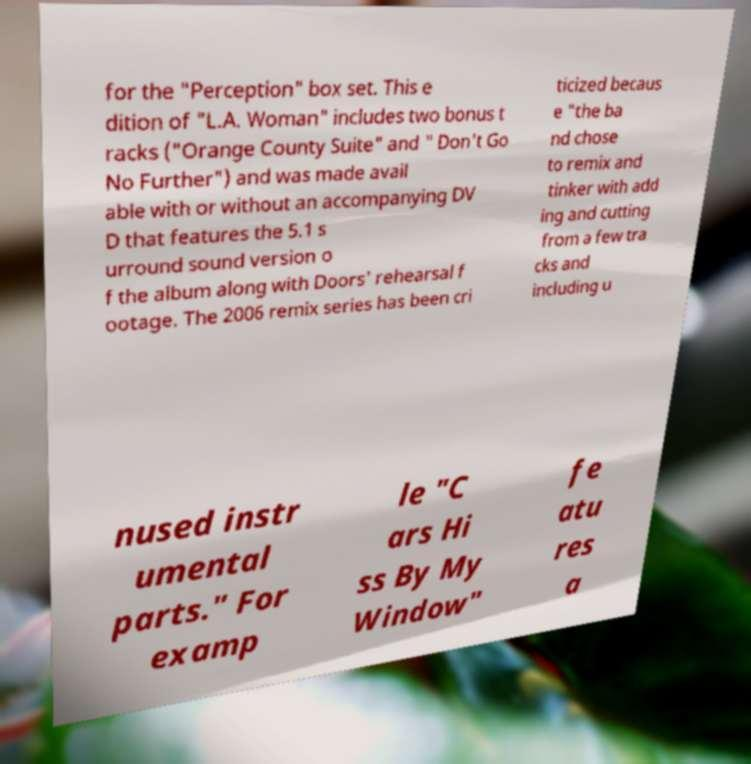Can you accurately transcribe the text from the provided image for me? for the "Perception" box set. This e dition of "L.A. Woman" includes two bonus t racks ("Orange County Suite" and " Don't Go No Further") and was made avail able with or without an accompanying DV D that features the 5.1 s urround sound version o f the album along with Doors' rehearsal f ootage. The 2006 remix series has been cri ticized becaus e "the ba nd chose to remix and tinker with add ing and cutting from a few tra cks and including u nused instr umental parts." For examp le "C ars Hi ss By My Window" fe atu res a 